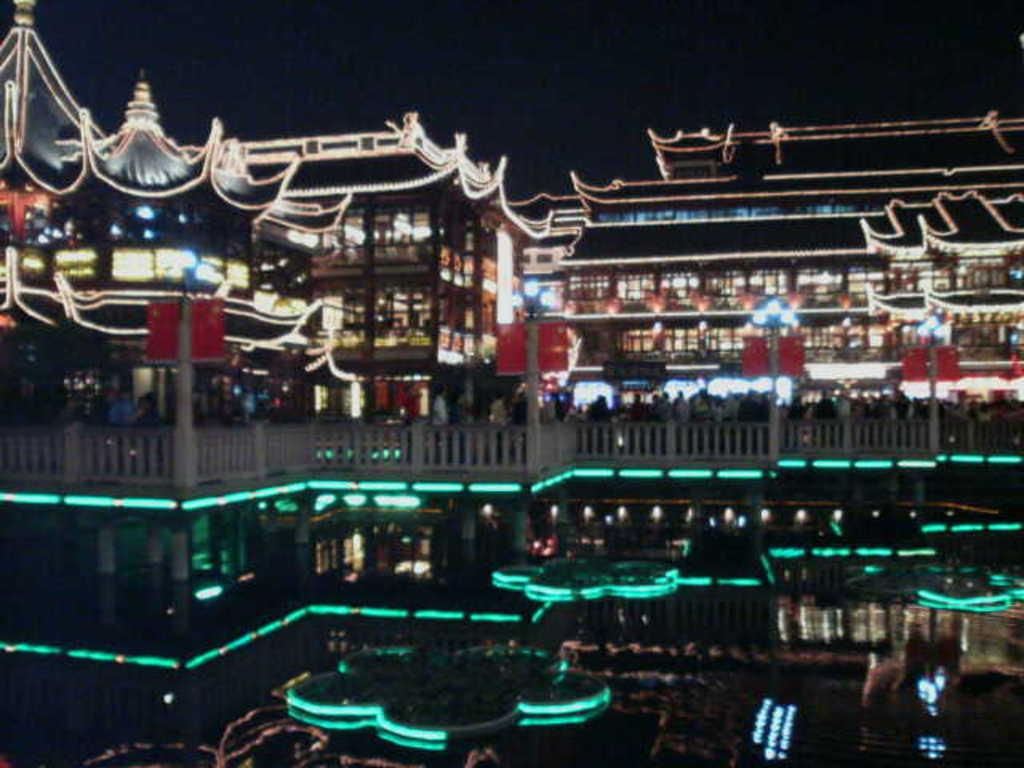What is at the bottom of the image? There is water at the bottom of the image. What is in the water? There is a ship in the water. How is the ship decorated? The ship is decorated with lights. What is visible at the top of the image? The sky is visible at the top of the image. What is the condition of the sky in the image? The sky is in the night. Can you tell me how many trucks are visible in the image? There are no trucks present in the image; it features a ship in the water. What type of shock can be seen affecting the ship in the image? There is no shock present in the image; the ship is decorated with lights and is in the water. 